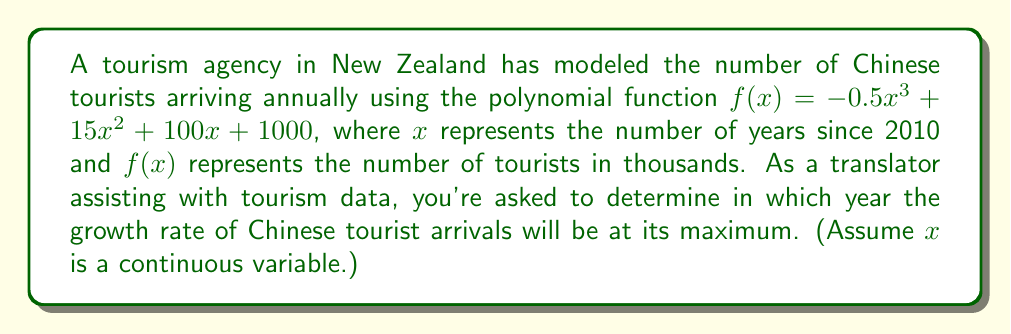Teach me how to tackle this problem. To find the year when the growth rate is at its maximum, we need to follow these steps:

1) The growth rate is represented by the first derivative of the function. Let's find $f'(x)$:
   $f'(x) = -1.5x^2 + 30x + 100$

2) The maximum growth rate will occur when the second derivative equals zero. Let's find $f''(x)$:
   $f''(x) = -3x + 30$

3) Set $f''(x) = 0$ and solve for $x$:
   $-3x + 30 = 0$
   $-3x = -30$
   $x = 10$

4) To confirm this is a maximum (not a minimum), we can check that $f'''(x) = -3 < 0$.

5) Since $x$ represents the number of years since 2010, we add 10 to 2010 to get the actual year:
   2010 + 10 = 2020

Therefore, the growth rate will be at its maximum in 2020.
Answer: 2020 